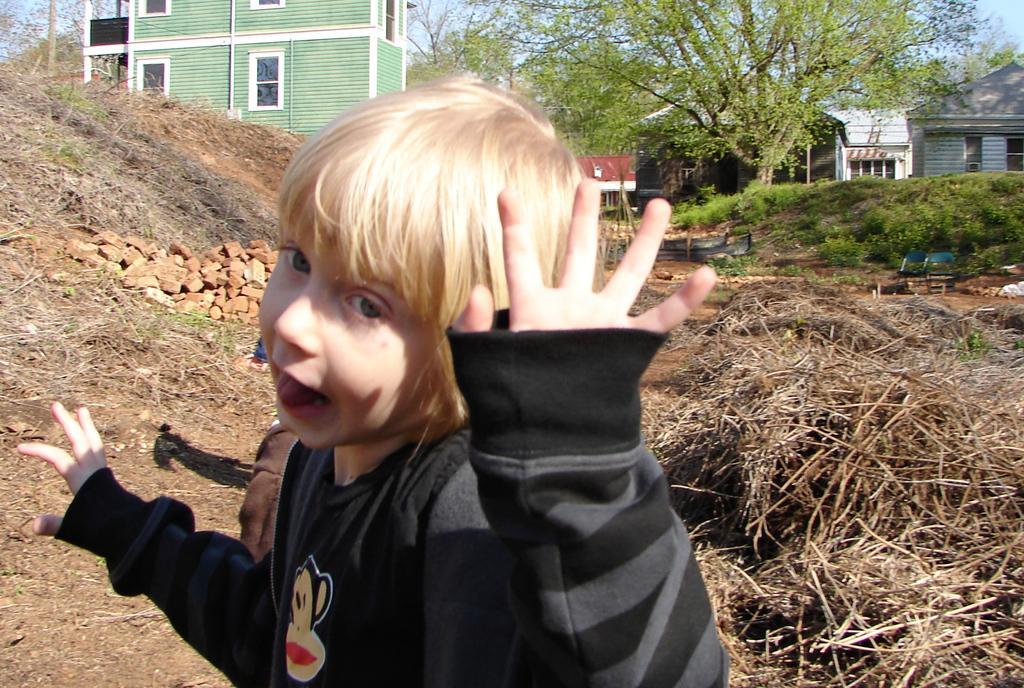In one or two sentences, can you explain what this image depicts? In this image we can see a child wearing black dress is standing here Here we can see dry grass, bricks, grass, wooden houses, trees and the sky in the background. 